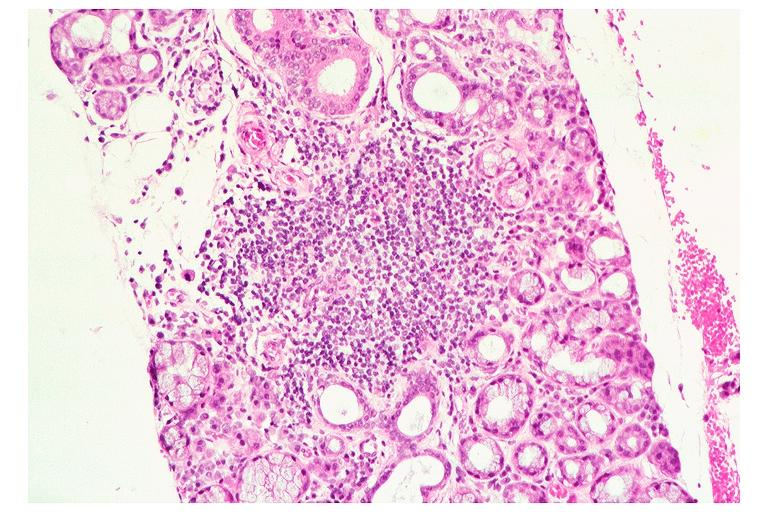s oral present?
Answer the question using a single word or phrase. Yes 